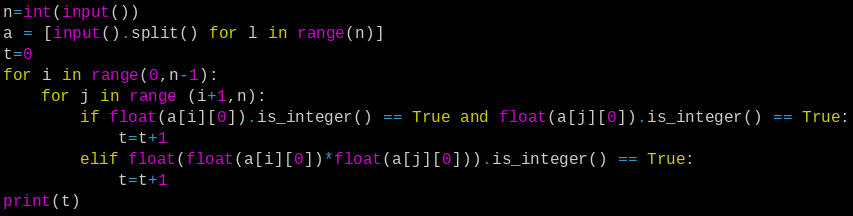<code> <loc_0><loc_0><loc_500><loc_500><_Python_>n=int(input())
a = [input().split() for l in range(n)]
t=0
for i in range(0,n-1):
    for j in range (i+1,n):
        if float(a[i][0]).is_integer() == True and float(a[j][0]).is_integer() == True:
            t=t+1
        elif float(float(a[i][0])*float(a[j][0])).is_integer() == True:
            t=t+1
print(t)</code> 